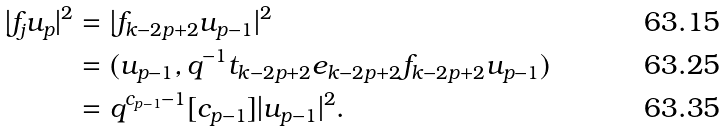Convert formula to latex. <formula><loc_0><loc_0><loc_500><loc_500>| f _ { j } u _ { p } | ^ { 2 } & = | f _ { k - 2 p + 2 } u _ { p - 1 } | ^ { 2 } \\ & = ( u _ { p - 1 } , q ^ { - 1 } t _ { k - 2 p + 2 } e _ { k - 2 p + 2 } f _ { k - 2 p + 2 } u _ { p - 1 } ) \\ & = q ^ { c _ { p - 1 } - 1 } [ c _ { p - 1 } ] | u _ { p - 1 } | ^ { 2 } .</formula> 